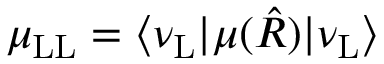<formula> <loc_0><loc_0><loc_500><loc_500>\mu _ { L L } = \langle \nu _ { L } | \mu ( \hat { R } ) | \nu _ { L } \rangle</formula> 